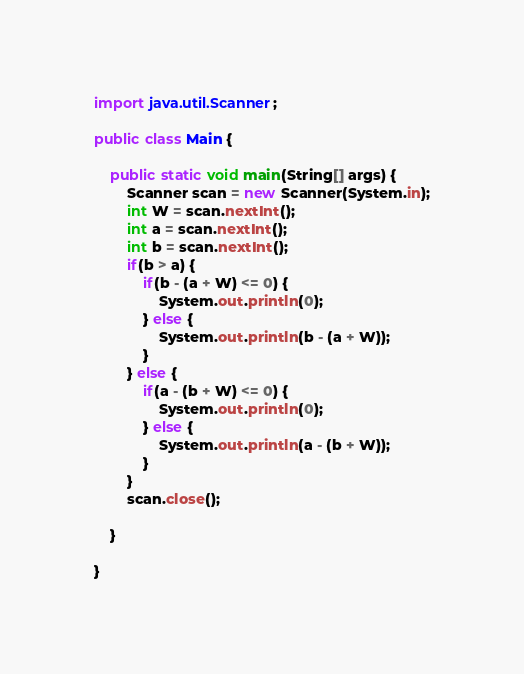<code> <loc_0><loc_0><loc_500><loc_500><_Java_>import java.util.Scanner;

public class Main {

	public static void main(String[] args) {
		Scanner scan = new Scanner(System.in);
		int W = scan.nextInt();
		int a = scan.nextInt();
		int b = scan.nextInt();
		if(b > a) {
			if(b - (a + W) <= 0) {
				System.out.println(0);
			} else {
				System.out.println(b - (a + W));
			}
		} else {
			if(a - (b + W) <= 0) {
				System.out.println(0);
			} else {
				System.out.println(a - (b + W));
			}
		}
		scan.close();

	}

}
</code> 